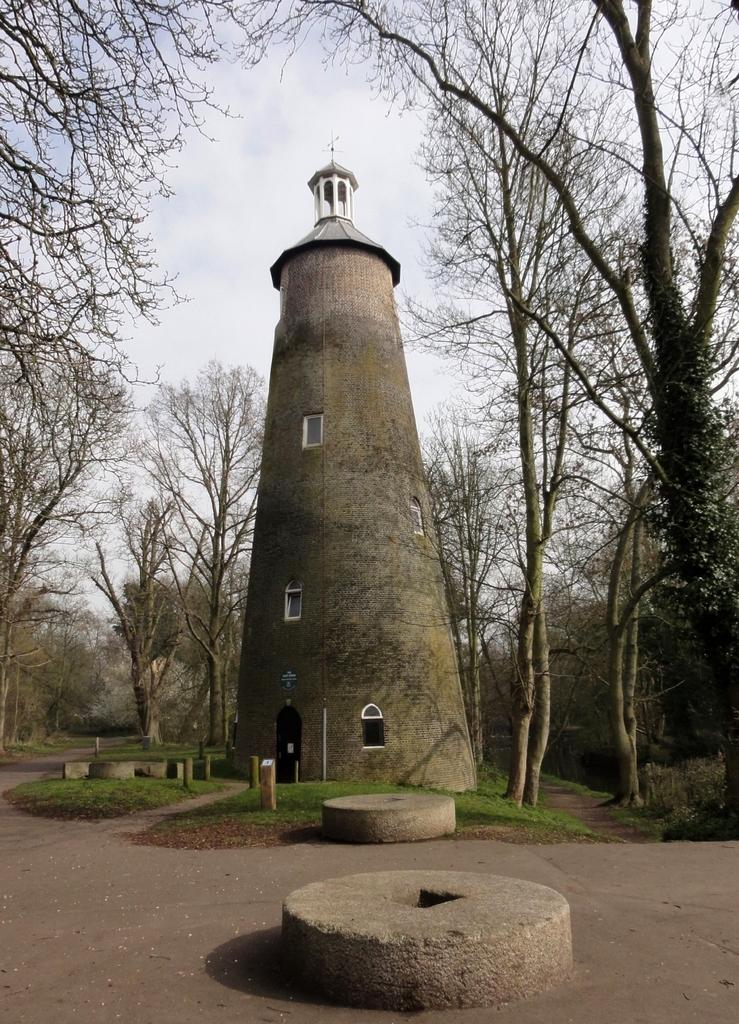What is the main structure in the center of the image? There is a tower in the center of the image. What can be seen in the background of the image? There are trees in the background of the image. What type of ground surface is visible at the bottom of the image? There are stones on the ground at the bottom of the image. What time of day is it in the image, and can you see any geese? The time of day is not mentioned in the image, and there are no geese present. 